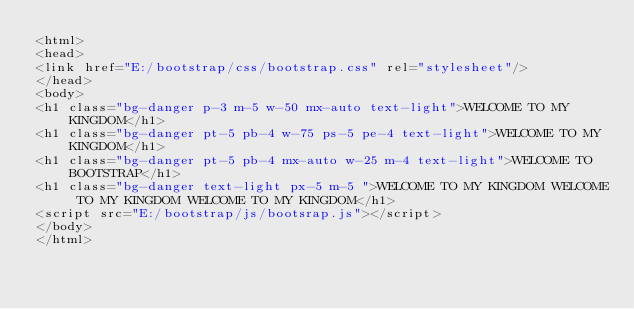<code> <loc_0><loc_0><loc_500><loc_500><_HTML_><html>
<head>
<link href="E:/bootstrap/css/bootstrap.css" rel="stylesheet"/>
</head>
<body>
<h1 class="bg-danger p-3 m-5 w-50 mx-auto text-light">WELCOME TO MY KINGDOM</h1>
<h1 class="bg-danger pt-5 pb-4 w-75 ps-5 pe-4 text-light">WELCOME TO MY KINGDOM</h1>
<h1 class="bg-danger pt-5 pb-4 mx-auto w-25 m-4 text-light">WELCOME TO BOOTSTRAP</h1>
<h1 class="bg-danger text-light px-5 m-5 ">WELCOME TO MY KINGDOM WELCOME TO MY KINGDOM WELCOME TO MY KINGDOM</h1>
<script src="E:/bootstrap/js/bootsrap.js"></script>
</body>
</html></code> 